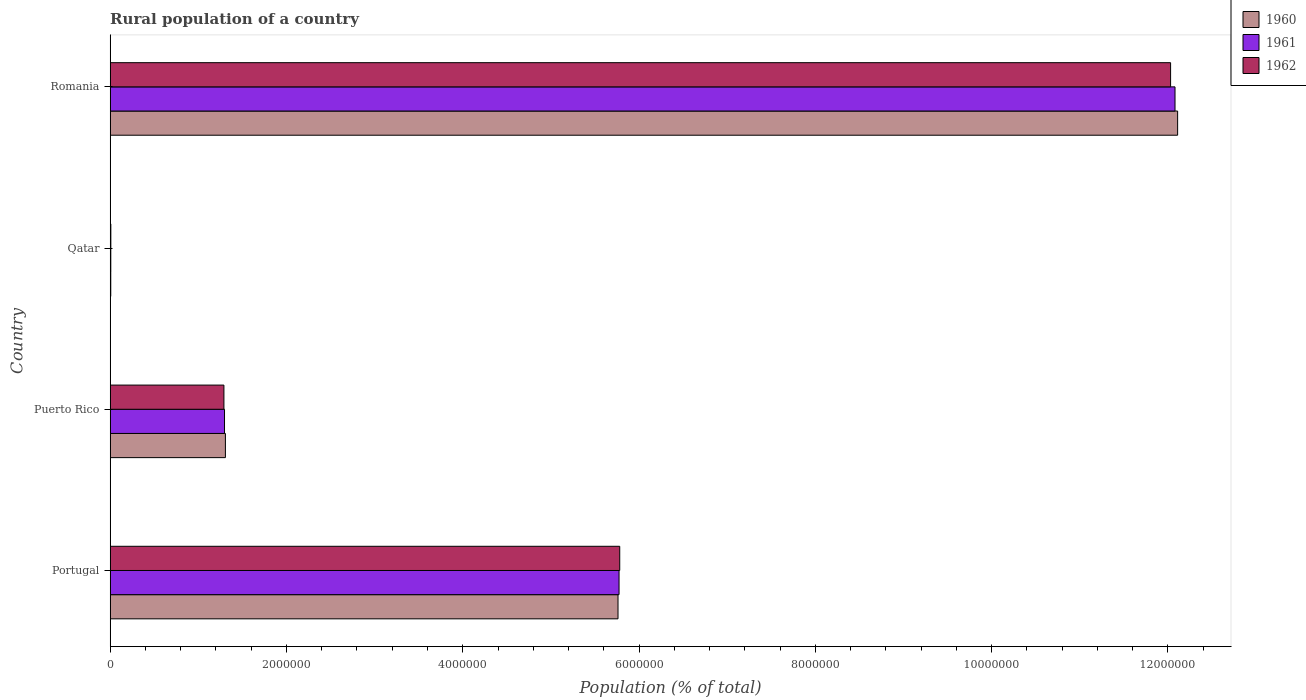Are the number of bars on each tick of the Y-axis equal?
Your response must be concise. Yes. How many bars are there on the 3rd tick from the top?
Provide a succinct answer. 3. What is the label of the 2nd group of bars from the top?
Keep it short and to the point. Qatar. In how many cases, is the number of bars for a given country not equal to the number of legend labels?
Offer a terse response. 0. What is the rural population in 1960 in Portugal?
Give a very brief answer. 5.76e+06. Across all countries, what is the maximum rural population in 1961?
Provide a short and direct response. 1.21e+07. Across all countries, what is the minimum rural population in 1962?
Ensure brevity in your answer.  7809. In which country was the rural population in 1960 maximum?
Your answer should be very brief. Romania. In which country was the rural population in 1961 minimum?
Make the answer very short. Qatar. What is the total rural population in 1962 in the graph?
Your answer should be compact. 1.91e+07. What is the difference between the rural population in 1962 in Portugal and that in Romania?
Keep it short and to the point. -6.25e+06. What is the difference between the rural population in 1961 in Romania and the rural population in 1960 in Portugal?
Ensure brevity in your answer.  6.32e+06. What is the average rural population in 1961 per country?
Provide a short and direct response. 4.79e+06. What is the difference between the rural population in 1961 and rural population in 1962 in Qatar?
Give a very brief answer. -462. What is the ratio of the rural population in 1961 in Puerto Rico to that in Qatar?
Ensure brevity in your answer.  176.6. Is the difference between the rural population in 1961 in Portugal and Qatar greater than the difference between the rural population in 1962 in Portugal and Qatar?
Keep it short and to the point. No. What is the difference between the highest and the second highest rural population in 1961?
Ensure brevity in your answer.  6.31e+06. What is the difference between the highest and the lowest rural population in 1962?
Ensure brevity in your answer.  1.20e+07. In how many countries, is the rural population in 1960 greater than the average rural population in 1960 taken over all countries?
Give a very brief answer. 2. What does the 1st bar from the top in Portugal represents?
Give a very brief answer. 1962. What does the 2nd bar from the bottom in Qatar represents?
Keep it short and to the point. 1961. Is it the case that in every country, the sum of the rural population in 1960 and rural population in 1961 is greater than the rural population in 1962?
Offer a terse response. Yes. Are all the bars in the graph horizontal?
Your response must be concise. Yes. Are the values on the major ticks of X-axis written in scientific E-notation?
Make the answer very short. No. Does the graph contain grids?
Your answer should be very brief. No. Where does the legend appear in the graph?
Offer a very short reply. Top right. How are the legend labels stacked?
Provide a short and direct response. Vertical. What is the title of the graph?
Provide a short and direct response. Rural population of a country. Does "1985" appear as one of the legend labels in the graph?
Provide a short and direct response. No. What is the label or title of the X-axis?
Give a very brief answer. Population (% of total). What is the label or title of the Y-axis?
Make the answer very short. Country. What is the Population (% of total) of 1960 in Portugal?
Offer a terse response. 5.76e+06. What is the Population (% of total) of 1961 in Portugal?
Your answer should be very brief. 5.77e+06. What is the Population (% of total) in 1962 in Portugal?
Your answer should be very brief. 5.78e+06. What is the Population (% of total) in 1960 in Puerto Rico?
Provide a succinct answer. 1.31e+06. What is the Population (% of total) in 1961 in Puerto Rico?
Your response must be concise. 1.30e+06. What is the Population (% of total) in 1962 in Puerto Rico?
Provide a succinct answer. 1.29e+06. What is the Population (% of total) of 1960 in Qatar?
Offer a terse response. 6966. What is the Population (% of total) in 1961 in Qatar?
Make the answer very short. 7347. What is the Population (% of total) in 1962 in Qatar?
Ensure brevity in your answer.  7809. What is the Population (% of total) in 1960 in Romania?
Provide a succinct answer. 1.21e+07. What is the Population (% of total) in 1961 in Romania?
Your answer should be very brief. 1.21e+07. What is the Population (% of total) in 1962 in Romania?
Offer a terse response. 1.20e+07. Across all countries, what is the maximum Population (% of total) of 1960?
Provide a succinct answer. 1.21e+07. Across all countries, what is the maximum Population (% of total) of 1961?
Offer a very short reply. 1.21e+07. Across all countries, what is the maximum Population (% of total) of 1962?
Make the answer very short. 1.20e+07. Across all countries, what is the minimum Population (% of total) of 1960?
Ensure brevity in your answer.  6966. Across all countries, what is the minimum Population (% of total) of 1961?
Ensure brevity in your answer.  7347. Across all countries, what is the minimum Population (% of total) in 1962?
Make the answer very short. 7809. What is the total Population (% of total) of 1960 in the graph?
Your answer should be compact. 1.92e+07. What is the total Population (% of total) in 1961 in the graph?
Ensure brevity in your answer.  1.92e+07. What is the total Population (% of total) in 1962 in the graph?
Give a very brief answer. 1.91e+07. What is the difference between the Population (% of total) in 1960 in Portugal and that in Puerto Rico?
Your answer should be compact. 4.45e+06. What is the difference between the Population (% of total) in 1961 in Portugal and that in Puerto Rico?
Ensure brevity in your answer.  4.48e+06. What is the difference between the Population (% of total) of 1962 in Portugal and that in Puerto Rico?
Provide a succinct answer. 4.49e+06. What is the difference between the Population (% of total) in 1960 in Portugal and that in Qatar?
Your answer should be compact. 5.75e+06. What is the difference between the Population (% of total) in 1961 in Portugal and that in Qatar?
Provide a short and direct response. 5.77e+06. What is the difference between the Population (% of total) of 1962 in Portugal and that in Qatar?
Provide a short and direct response. 5.77e+06. What is the difference between the Population (% of total) of 1960 in Portugal and that in Romania?
Provide a short and direct response. -6.35e+06. What is the difference between the Population (% of total) of 1961 in Portugal and that in Romania?
Keep it short and to the point. -6.31e+06. What is the difference between the Population (% of total) of 1962 in Portugal and that in Romania?
Give a very brief answer. -6.25e+06. What is the difference between the Population (% of total) in 1960 in Puerto Rico and that in Qatar?
Give a very brief answer. 1.30e+06. What is the difference between the Population (% of total) in 1961 in Puerto Rico and that in Qatar?
Your response must be concise. 1.29e+06. What is the difference between the Population (% of total) of 1962 in Puerto Rico and that in Qatar?
Offer a terse response. 1.28e+06. What is the difference between the Population (% of total) in 1960 in Puerto Rico and that in Romania?
Your response must be concise. -1.08e+07. What is the difference between the Population (% of total) of 1961 in Puerto Rico and that in Romania?
Your response must be concise. -1.08e+07. What is the difference between the Population (% of total) of 1962 in Puerto Rico and that in Romania?
Your response must be concise. -1.07e+07. What is the difference between the Population (% of total) of 1960 in Qatar and that in Romania?
Your answer should be very brief. -1.21e+07. What is the difference between the Population (% of total) in 1961 in Qatar and that in Romania?
Ensure brevity in your answer.  -1.21e+07. What is the difference between the Population (% of total) of 1962 in Qatar and that in Romania?
Your answer should be compact. -1.20e+07. What is the difference between the Population (% of total) in 1960 in Portugal and the Population (% of total) in 1961 in Puerto Rico?
Your response must be concise. 4.46e+06. What is the difference between the Population (% of total) in 1960 in Portugal and the Population (% of total) in 1962 in Puerto Rico?
Provide a short and direct response. 4.47e+06. What is the difference between the Population (% of total) in 1961 in Portugal and the Population (% of total) in 1962 in Puerto Rico?
Your answer should be very brief. 4.48e+06. What is the difference between the Population (% of total) in 1960 in Portugal and the Population (% of total) in 1961 in Qatar?
Offer a terse response. 5.75e+06. What is the difference between the Population (% of total) in 1960 in Portugal and the Population (% of total) in 1962 in Qatar?
Offer a terse response. 5.75e+06. What is the difference between the Population (% of total) in 1961 in Portugal and the Population (% of total) in 1962 in Qatar?
Provide a succinct answer. 5.77e+06. What is the difference between the Population (% of total) in 1960 in Portugal and the Population (% of total) in 1961 in Romania?
Keep it short and to the point. -6.32e+06. What is the difference between the Population (% of total) in 1960 in Portugal and the Population (% of total) in 1962 in Romania?
Make the answer very short. -6.27e+06. What is the difference between the Population (% of total) in 1961 in Portugal and the Population (% of total) in 1962 in Romania?
Give a very brief answer. -6.26e+06. What is the difference between the Population (% of total) in 1960 in Puerto Rico and the Population (% of total) in 1961 in Qatar?
Give a very brief answer. 1.30e+06. What is the difference between the Population (% of total) of 1960 in Puerto Rico and the Population (% of total) of 1962 in Qatar?
Your answer should be very brief. 1.30e+06. What is the difference between the Population (% of total) of 1961 in Puerto Rico and the Population (% of total) of 1962 in Qatar?
Your answer should be compact. 1.29e+06. What is the difference between the Population (% of total) of 1960 in Puerto Rico and the Population (% of total) of 1961 in Romania?
Your answer should be compact. -1.08e+07. What is the difference between the Population (% of total) of 1960 in Puerto Rico and the Population (% of total) of 1962 in Romania?
Your answer should be compact. -1.07e+07. What is the difference between the Population (% of total) of 1961 in Puerto Rico and the Population (% of total) of 1962 in Romania?
Your answer should be very brief. -1.07e+07. What is the difference between the Population (% of total) of 1960 in Qatar and the Population (% of total) of 1961 in Romania?
Offer a very short reply. -1.21e+07. What is the difference between the Population (% of total) in 1960 in Qatar and the Population (% of total) in 1962 in Romania?
Give a very brief answer. -1.20e+07. What is the difference between the Population (% of total) of 1961 in Qatar and the Population (% of total) of 1962 in Romania?
Provide a short and direct response. -1.20e+07. What is the average Population (% of total) in 1960 per country?
Offer a terse response. 4.80e+06. What is the average Population (% of total) in 1961 per country?
Provide a short and direct response. 4.79e+06. What is the average Population (% of total) of 1962 per country?
Provide a succinct answer. 4.78e+06. What is the difference between the Population (% of total) in 1960 and Population (% of total) in 1961 in Portugal?
Offer a very short reply. -1.18e+04. What is the difference between the Population (% of total) of 1960 and Population (% of total) of 1962 in Portugal?
Your answer should be compact. -1.97e+04. What is the difference between the Population (% of total) in 1961 and Population (% of total) in 1962 in Portugal?
Provide a succinct answer. -7815. What is the difference between the Population (% of total) in 1960 and Population (% of total) in 1961 in Puerto Rico?
Offer a terse response. 1.01e+04. What is the difference between the Population (% of total) in 1960 and Population (% of total) in 1962 in Puerto Rico?
Your response must be concise. 1.69e+04. What is the difference between the Population (% of total) of 1961 and Population (% of total) of 1962 in Puerto Rico?
Make the answer very short. 6800. What is the difference between the Population (% of total) in 1960 and Population (% of total) in 1961 in Qatar?
Make the answer very short. -381. What is the difference between the Population (% of total) of 1960 and Population (% of total) of 1962 in Qatar?
Ensure brevity in your answer.  -843. What is the difference between the Population (% of total) in 1961 and Population (% of total) in 1962 in Qatar?
Give a very brief answer. -462. What is the difference between the Population (% of total) in 1960 and Population (% of total) in 1961 in Romania?
Your response must be concise. 2.95e+04. What is the difference between the Population (% of total) of 1960 and Population (% of total) of 1962 in Romania?
Your answer should be compact. 7.98e+04. What is the difference between the Population (% of total) in 1961 and Population (% of total) in 1962 in Romania?
Give a very brief answer. 5.03e+04. What is the ratio of the Population (% of total) in 1960 in Portugal to that in Puerto Rico?
Your answer should be compact. 4.41. What is the ratio of the Population (% of total) of 1961 in Portugal to that in Puerto Rico?
Give a very brief answer. 4.45. What is the ratio of the Population (% of total) of 1962 in Portugal to that in Puerto Rico?
Offer a very short reply. 4.48. What is the ratio of the Population (% of total) of 1960 in Portugal to that in Qatar?
Provide a succinct answer. 827.09. What is the ratio of the Population (% of total) in 1961 in Portugal to that in Qatar?
Offer a very short reply. 785.81. What is the ratio of the Population (% of total) in 1962 in Portugal to that in Qatar?
Your answer should be compact. 740.32. What is the ratio of the Population (% of total) in 1960 in Portugal to that in Romania?
Give a very brief answer. 0.48. What is the ratio of the Population (% of total) of 1961 in Portugal to that in Romania?
Give a very brief answer. 0.48. What is the ratio of the Population (% of total) of 1962 in Portugal to that in Romania?
Your response must be concise. 0.48. What is the ratio of the Population (% of total) of 1960 in Puerto Rico to that in Qatar?
Provide a short and direct response. 187.71. What is the ratio of the Population (% of total) of 1961 in Puerto Rico to that in Qatar?
Give a very brief answer. 176.6. What is the ratio of the Population (% of total) of 1962 in Puerto Rico to that in Qatar?
Provide a short and direct response. 165.28. What is the ratio of the Population (% of total) of 1960 in Puerto Rico to that in Romania?
Your answer should be compact. 0.11. What is the ratio of the Population (% of total) of 1961 in Puerto Rico to that in Romania?
Your answer should be very brief. 0.11. What is the ratio of the Population (% of total) in 1962 in Puerto Rico to that in Romania?
Your answer should be compact. 0.11. What is the ratio of the Population (% of total) of 1960 in Qatar to that in Romania?
Provide a succinct answer. 0. What is the ratio of the Population (% of total) in 1961 in Qatar to that in Romania?
Ensure brevity in your answer.  0. What is the ratio of the Population (% of total) in 1962 in Qatar to that in Romania?
Offer a very short reply. 0. What is the difference between the highest and the second highest Population (% of total) in 1960?
Give a very brief answer. 6.35e+06. What is the difference between the highest and the second highest Population (% of total) in 1961?
Ensure brevity in your answer.  6.31e+06. What is the difference between the highest and the second highest Population (% of total) in 1962?
Your answer should be very brief. 6.25e+06. What is the difference between the highest and the lowest Population (% of total) of 1960?
Offer a terse response. 1.21e+07. What is the difference between the highest and the lowest Population (% of total) of 1961?
Your answer should be very brief. 1.21e+07. What is the difference between the highest and the lowest Population (% of total) of 1962?
Your answer should be very brief. 1.20e+07. 